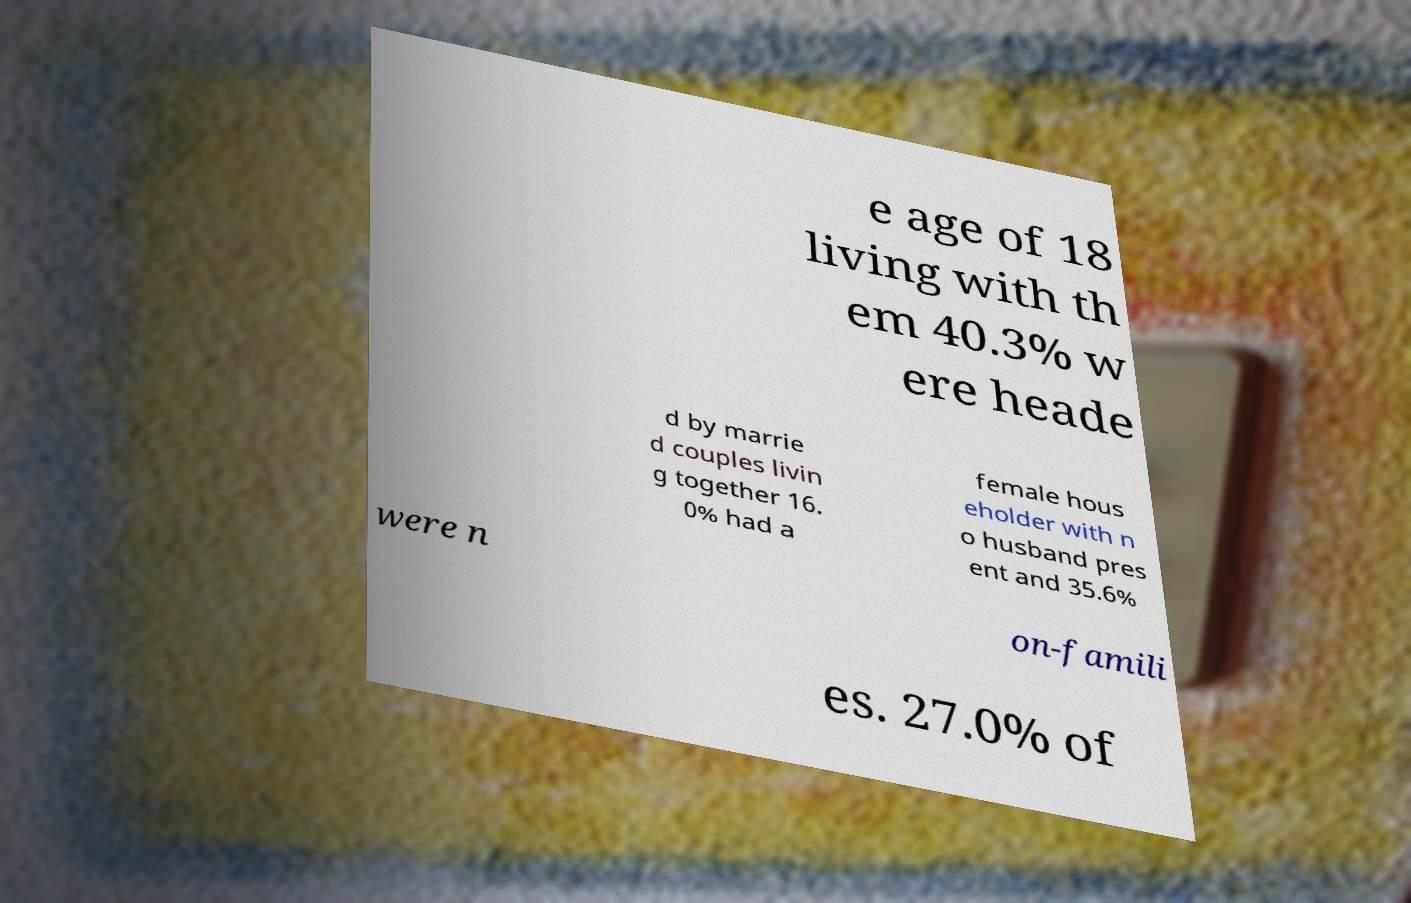Can you accurately transcribe the text from the provided image for me? e age of 18 living with th em 40.3% w ere heade d by marrie d couples livin g together 16. 0% had a female hous eholder with n o husband pres ent and 35.6% were n on-famili es. 27.0% of 